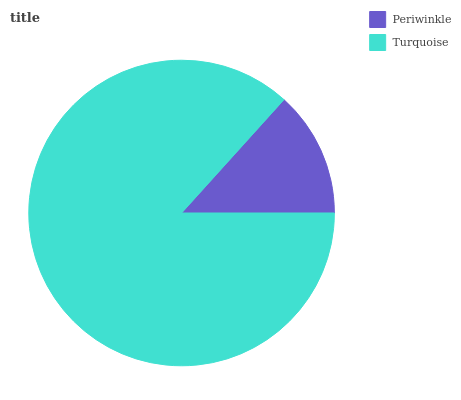Is Periwinkle the minimum?
Answer yes or no. Yes. Is Turquoise the maximum?
Answer yes or no. Yes. Is Turquoise the minimum?
Answer yes or no. No. Is Turquoise greater than Periwinkle?
Answer yes or no. Yes. Is Periwinkle less than Turquoise?
Answer yes or no. Yes. Is Periwinkle greater than Turquoise?
Answer yes or no. No. Is Turquoise less than Periwinkle?
Answer yes or no. No. Is Turquoise the high median?
Answer yes or no. Yes. Is Periwinkle the low median?
Answer yes or no. Yes. Is Periwinkle the high median?
Answer yes or no. No. Is Turquoise the low median?
Answer yes or no. No. 